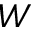<formula> <loc_0><loc_0><loc_500><loc_500>W</formula> 